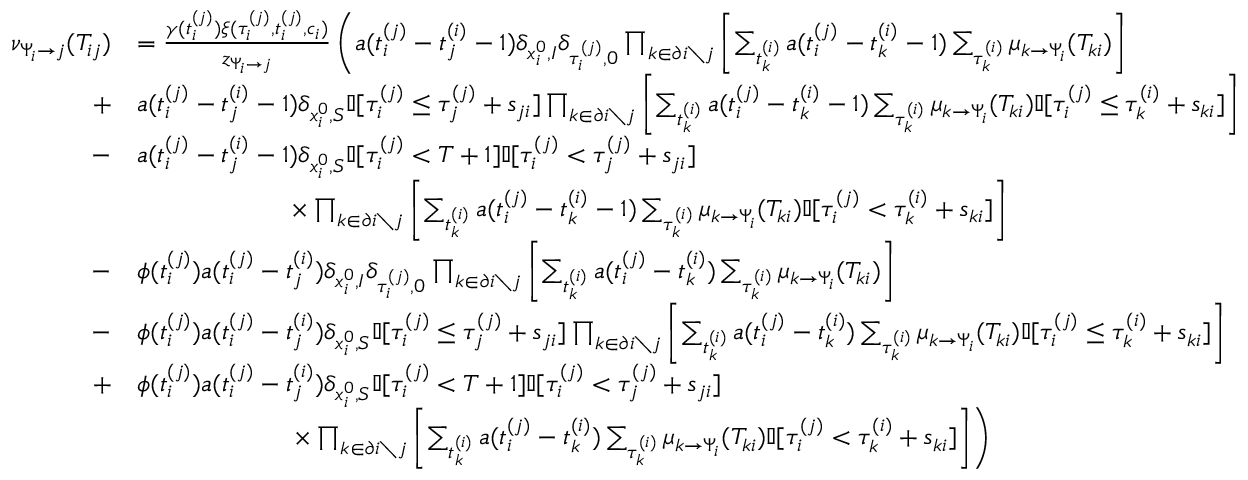<formula> <loc_0><loc_0><loc_500><loc_500>\begin{array} { r } { \begin{array} { r l } { \nu _ { \Psi _ { i } \to j } ( T _ { i j } ) } & { = \frac { \gamma ( t _ { i } ^ { ( j ) } ) \xi ( \tau _ { i } ^ { ( j ) } , t _ { i } ^ { ( j ) } , c _ { i } ) } { z _ { \Psi _ { i } \to j } } \left ( a ( t _ { i } ^ { ( j ) } - t _ { j } ^ { ( i ) } - 1 ) \delta _ { x _ { i } ^ { 0 } , I } \delta _ { \tau _ { i } ^ { ( j ) } , 0 } \prod _ { k \in \partial i \ j } \left [ \sum _ { t _ { k } ^ { ( i ) } } a ( t _ { i } ^ { ( j ) } - t _ { k } ^ { ( i ) } - 1 ) \sum _ { \tau _ { k } ^ { ( i ) } } \mu _ { k \to \Psi _ { i } } ( T _ { k i } ) \right ] } \\ { + } & { a ( t _ { i } ^ { ( j ) } - t _ { j } ^ { ( i ) } - 1 ) \delta _ { x _ { i } ^ { 0 } , S } \mathbb { I } [ \tau _ { i } ^ { ( j ) } \leq \tau _ { j } ^ { ( j ) } + s _ { j i } ] \prod _ { k \in \partial i \ j } \left [ \sum _ { t _ { k } ^ { ( i ) } } a ( t _ { i } ^ { ( j ) } - t _ { k } ^ { ( i ) } - 1 ) \sum _ { \tau _ { k } ^ { ( i ) } } \mu _ { k \to \Psi _ { i } } ( T _ { k i } ) \mathbb { I } [ \tau _ { i } ^ { ( j ) } \leq \tau _ { k } ^ { ( i ) } + s _ { k i } ] \right ] } \\ { - } & { a ( t _ { i } ^ { ( j ) } - t _ { j } ^ { ( i ) } - 1 ) \delta _ { x _ { i } ^ { 0 } , S } \mathbb { I } [ \tau _ { i } ^ { ( j ) } < T + 1 ] \mathbb { I } [ \tau _ { i } ^ { ( j ) } < \tau _ { j } ^ { ( j ) } + s _ { j i } ] } \\ & { \quad \times \prod _ { k \in \partial i \ j } \left [ \sum _ { t _ { k } ^ { ( i ) } } a ( t _ { i } ^ { ( j ) } - t _ { k } ^ { ( i ) } - 1 ) \sum _ { \tau _ { k } ^ { ( i ) } } \mu _ { k \to \Psi _ { i } } ( T _ { k i } ) \mathbb { I } [ \tau _ { i } ^ { ( j ) } < \tau _ { k } ^ { ( i ) } + s _ { k i } ] \right ] } \\ { - } & { \phi ( t _ { i } ^ { ( j ) } ) a ( t _ { i } ^ { ( j ) } - t _ { j } ^ { ( i ) } ) \delta _ { x _ { i } ^ { 0 } , I } \delta _ { \tau _ { i } ^ { ( j ) } , 0 } \prod _ { k \in \partial i \ j } \left [ \sum _ { t _ { k } ^ { ( i ) } } a ( t _ { i } ^ { ( j ) } - t _ { k } ^ { ( i ) } ) \sum _ { \tau _ { k } ^ { ( i ) } } \mu _ { k \to \Psi _ { i } } ( T _ { k i } ) \right ] } \\ { - } & { \phi ( t _ { i } ^ { ( j ) } ) a ( t _ { i } ^ { ( j ) } - t _ { j } ^ { ( i ) } ) \delta _ { x _ { i } ^ { 0 } , S } \mathbb { I } [ \tau _ { i } ^ { ( j ) } \leq \tau _ { j } ^ { ( j ) } + s _ { j i } ] \prod _ { k \in \partial i \ j } \left [ \sum _ { t _ { k } ^ { ( i ) } } a ( t _ { i } ^ { ( j ) } - t _ { k } ^ { ( i ) } ) \sum _ { \tau _ { k } ^ { ( i ) } } \mu _ { k \to \Psi _ { i } } ( T _ { k i } ) \mathbb { I } [ \tau _ { i } ^ { ( j ) } \leq \tau _ { k } ^ { ( i ) } + s _ { k i } ] \right ] } \\ { + } & { \phi ( t _ { i } ^ { ( j ) } ) a ( t _ { i } ^ { ( j ) } - t _ { j } ^ { ( i ) } ) \delta _ { x _ { i } ^ { 0 } , S } \mathbb { I } [ \tau _ { i } ^ { ( j ) } < T + 1 ] \mathbb { I } [ \tau _ { i } ^ { ( j ) } < \tau _ { j } ^ { ( j ) } + s _ { j i } ] } \\ & { \quad \times \prod _ { k \in \partial i \ j } \left [ \sum _ { t _ { k } ^ { ( i ) } } a ( t _ { i } ^ { ( j ) } - t _ { k } ^ { ( i ) } ) \sum _ { \tau _ { k } ^ { ( i ) } } \mu _ { k \to \Psi _ { i } } ( T _ { k i } ) \mathbb { I } [ \tau _ { i } ^ { ( j ) } < \tau _ { k } ^ { ( i ) } + s _ { k i } ] \right ] \right ) } \end{array} } \end{array}</formula> 